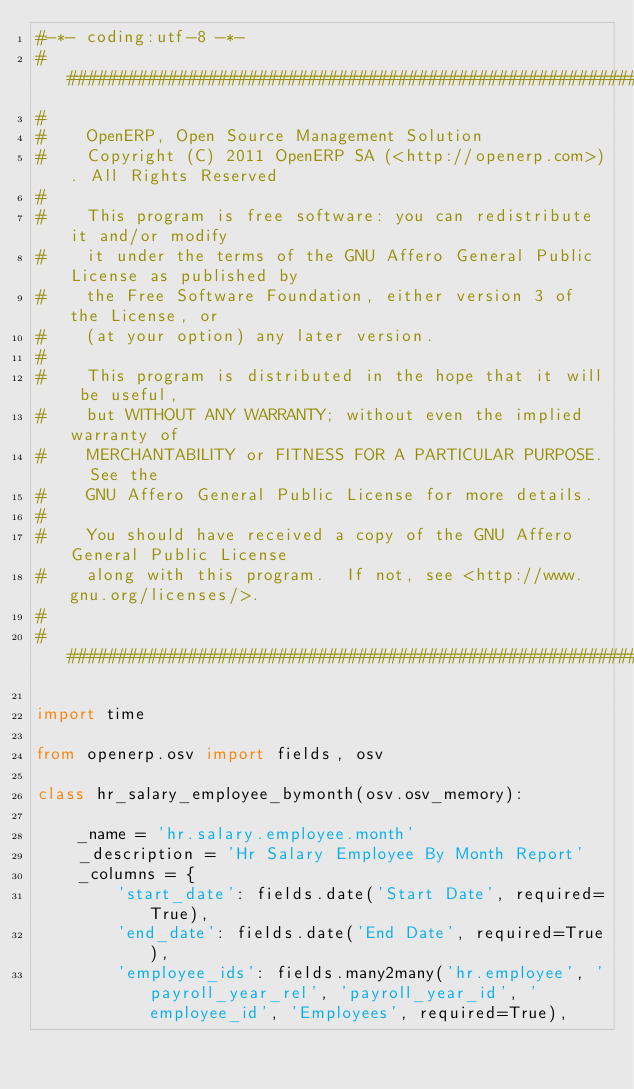<code> <loc_0><loc_0><loc_500><loc_500><_Python_>#-*- coding:utf-8 -*-
##############################################################################
#
#    OpenERP, Open Source Management Solution
#    Copyright (C) 2011 OpenERP SA (<http://openerp.com>). All Rights Reserved
#
#    This program is free software: you can redistribute it and/or modify
#    it under the terms of the GNU Affero General Public License as published by
#    the Free Software Foundation, either version 3 of the License, or
#    (at your option) any later version.
#
#    This program is distributed in the hope that it will be useful,
#    but WITHOUT ANY WARRANTY; without even the implied warranty of
#    MERCHANTABILITY or FITNESS FOR A PARTICULAR PURPOSE.  See the
#    GNU Affero General Public License for more details.
#
#    You should have received a copy of the GNU Affero General Public License
#    along with this program.  If not, see <http://www.gnu.org/licenses/>.
#
##############################################################################

import time

from openerp.osv import fields, osv

class hr_salary_employee_bymonth(osv.osv_memory):

    _name = 'hr.salary.employee.month'
    _description = 'Hr Salary Employee By Month Report'
    _columns = {
        'start_date': fields.date('Start Date', required=True),
        'end_date': fields.date('End Date', required=True),
        'employee_ids': fields.many2many('hr.employee', 'payroll_year_rel', 'payroll_year_id', 'employee_id', 'Employees', required=True),</code> 